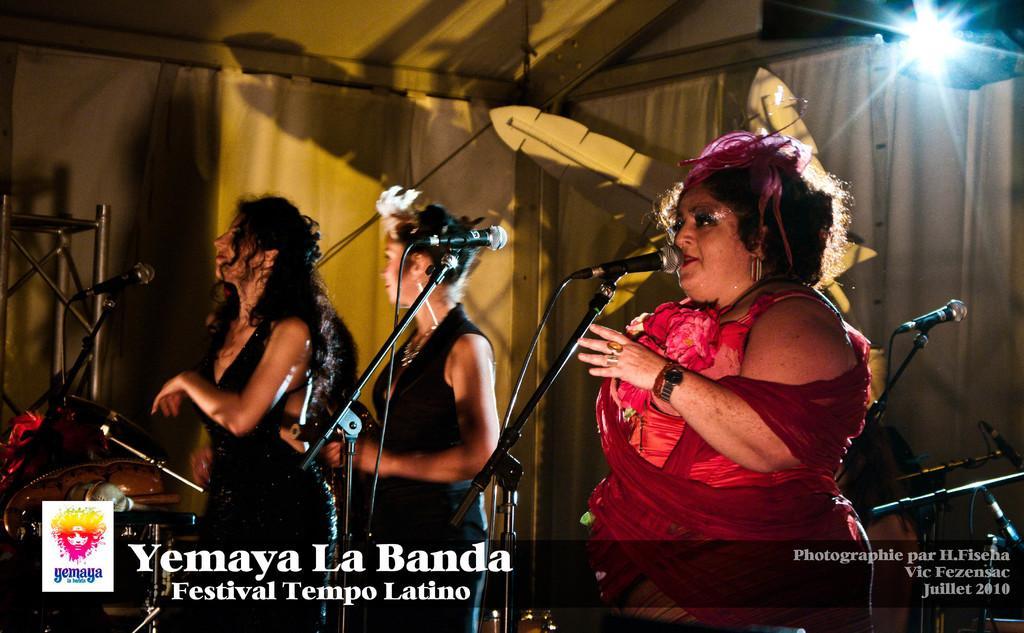Describe this image in one or two sentences. In this image we can see three women two are wearing black color dress and a woman wearing red color dress singing together, there are some microphones in front of them and in the background of the image there are some microphones near the drums and there is white color sheet and light. 